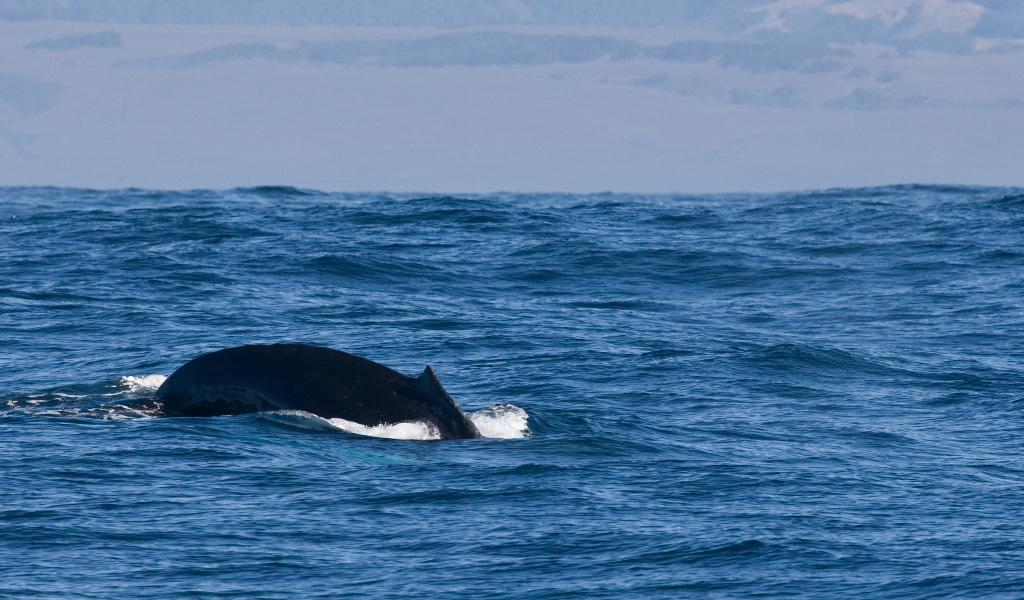What is the animal doing in the water? The animal is swimming in the water. What type of water can be seen in the image? There is an ocean in the background of the image. What else is visible in the background of the image? The sky is visible in the background of the image. Where is the sheep sitting on a swing in the image? There is no sheep or swing present in the image. What type of jam is being spread on the animal in the water? There is no jam or spreading activity present in the image. 